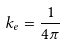Convert formula to latex. <formula><loc_0><loc_0><loc_500><loc_500>k _ { e } = { \frac { 1 } { 4 \pi } }</formula> 